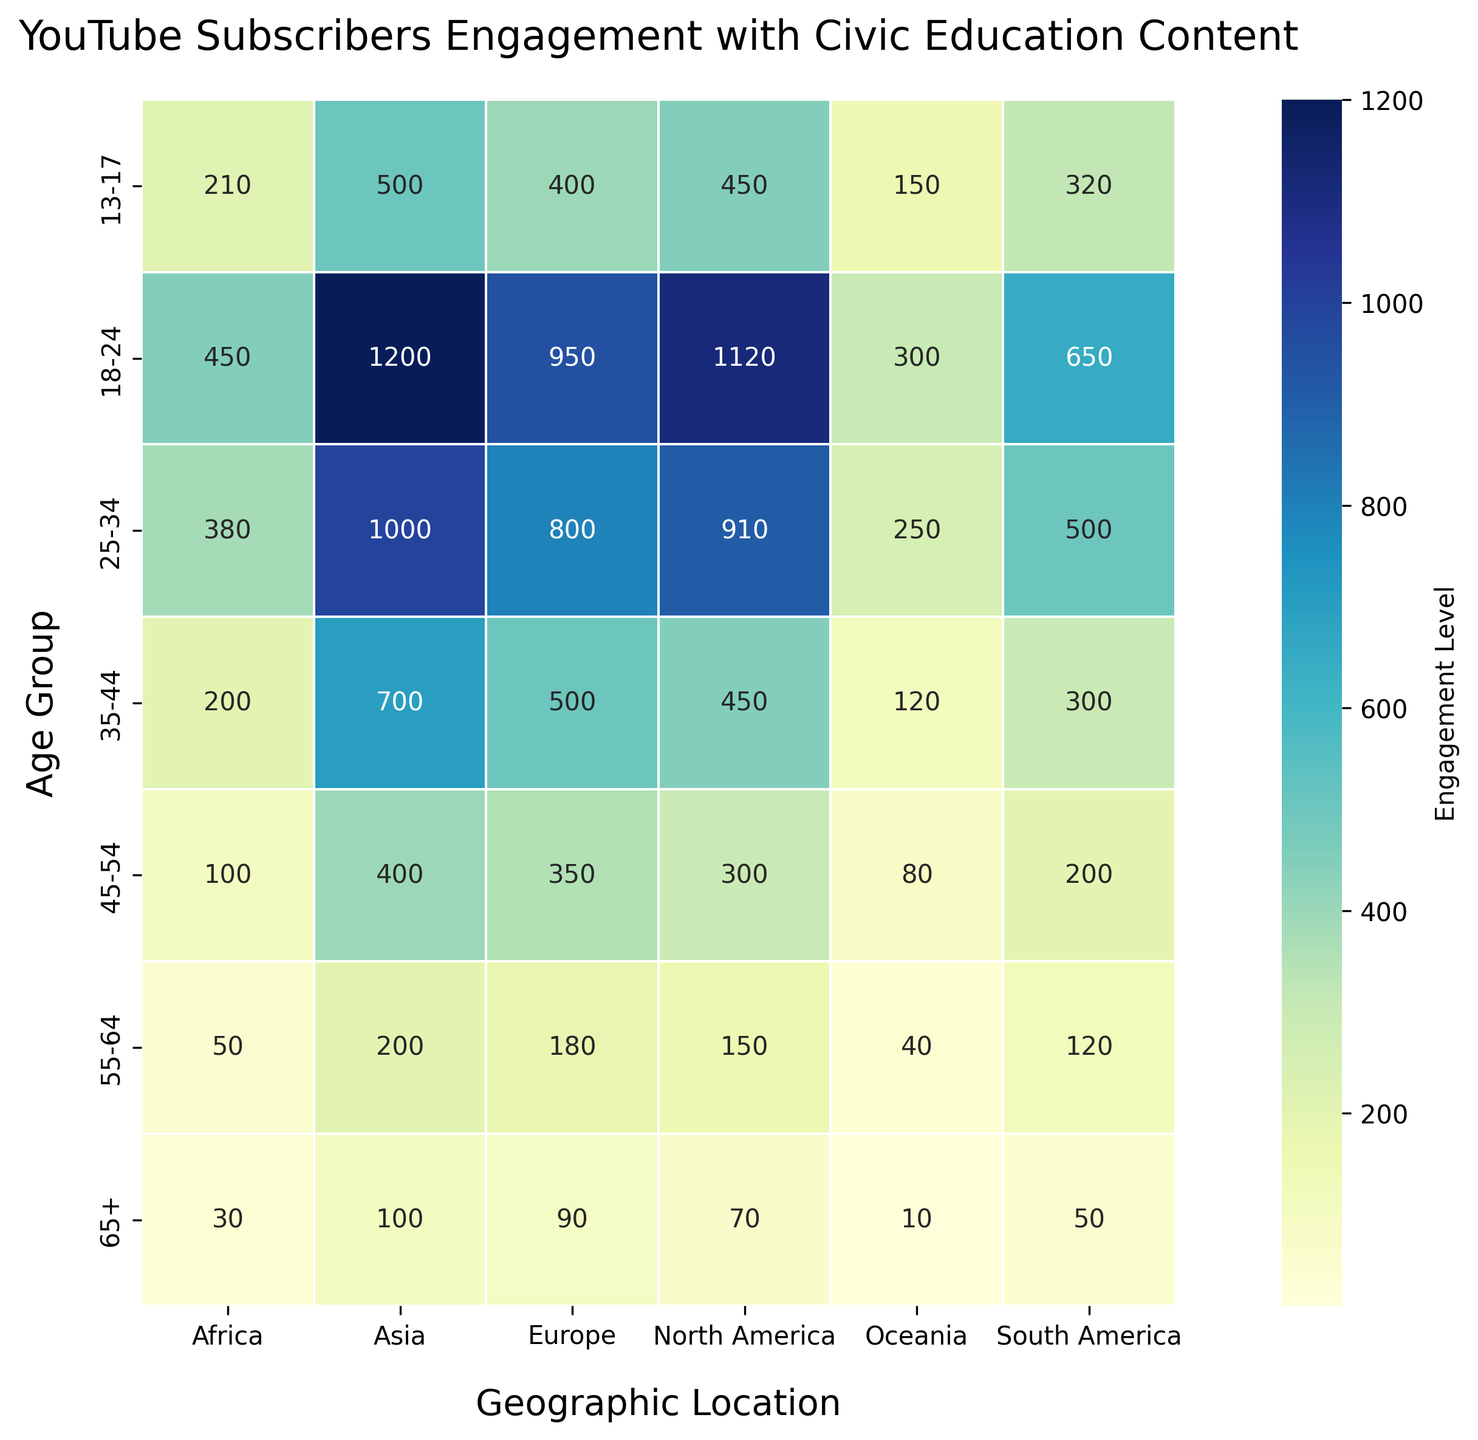What age group in Asia has the highest engagement level? Look at the column for Asia and find the age group with the highest number. The highest engagement level is 1200, which corresponds to the 18-24 age group.
Answer: 18-24 Between North America and Europe, which geographic location has a higher engagement level for the 25-34 age group? Compare the engagement levels in the 25-34 age group for both locations. North America has 910, and Europe has 800. So, North America has a higher engagement level for the 25-34 age group.
Answer: North America What is the total engagement level for subscribers aged 35-44 across all geographic locations? Locate the 35-44 row and sum the engagement levels for all geographic locations: 450 (North America) + 300 (South America) + 500 (Europe) + 200 (Africa) + 700 (Asia) + 120 (Oceania) = 2270.
Answer: 2270 Which age group has the lowest engagement level in Oceania? Look at the column for Oceania and find the smallest number. The smallest engagement level is 10, which corresponds to the 65+ age group.
Answer: 65+ Is the engagement level for the 18-24 age group in Europe greater than that in South America? Compare the engagement levels for the 18-24 age group between Europe and South America. Europe has an engagement level of 950, whereas South America has 650. Since 950 is greater than 650, Europe's engagement level is higher.
Answer: Yes How does the engagement level for the 18-24 age group in North America compare to that in Asia? Compare the engagement levels for the 18-24 age group. North America has 1120, and Asia has 1200. Since 1200 is greater than 1120, Asia’s engagement level is higher.
Answer: Asia What is the average engagement level for the 45-54 age group across all geographic locations? Locate the 45-54 row and sum the engagement levels for all geographic locations: 300 (North America) + 200 (South America) + 350 (Europe) + 100 (Africa) + 400 (Asia) + 80 (Oceania) = 1430. Divide the total by the number of locations: 1430 / 6 = 238.33.
Answer: 238.33 Which geographic location has the highest engagement level for the 13-17 age group? Look at the 13-17 row and find the highest number. The highest engagement level is 500, which corresponds to Asia.
Answer: Asia How much higher is the engagement level for 25-34 in Asia compared to Africa? Subtract the engagement level in Africa from the engagement level in Asia for the 25-34 age group: 1000 (Asia) - 380 (Africa) = 620.
Answer: 620 Does the 55-64 age group in South America have a higher engagement level than the 65+ age group in North America? Compare the engagement levels: South America (55-64) has 120 and North America (65+) has 70. Since 120 is greater than 70, South America's engagement level is higher.
Answer: Yes 